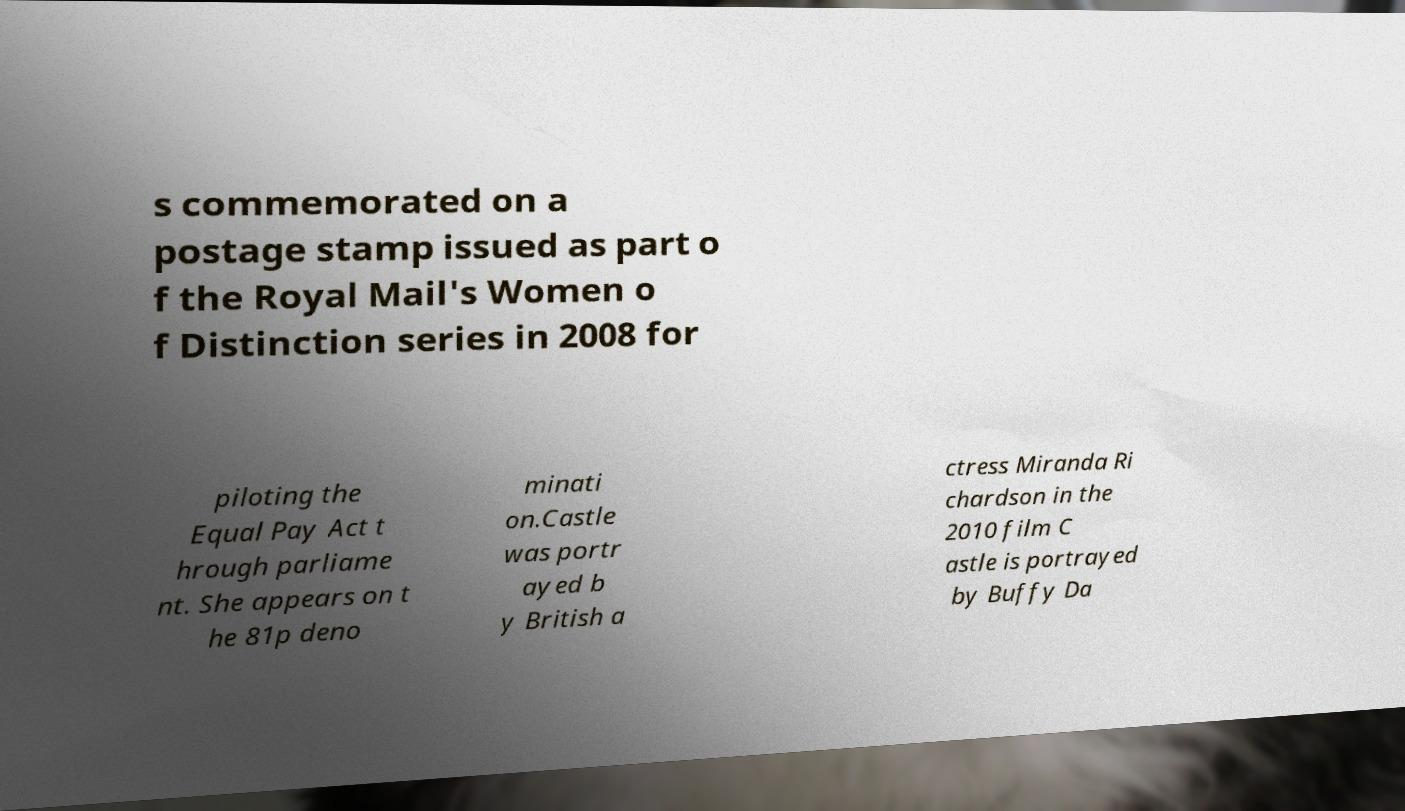I need the written content from this picture converted into text. Can you do that? s commemorated on a postage stamp issued as part o f the Royal Mail's Women o f Distinction series in 2008 for piloting the Equal Pay Act t hrough parliame nt. She appears on t he 81p deno minati on.Castle was portr ayed b y British a ctress Miranda Ri chardson in the 2010 film C astle is portrayed by Buffy Da 